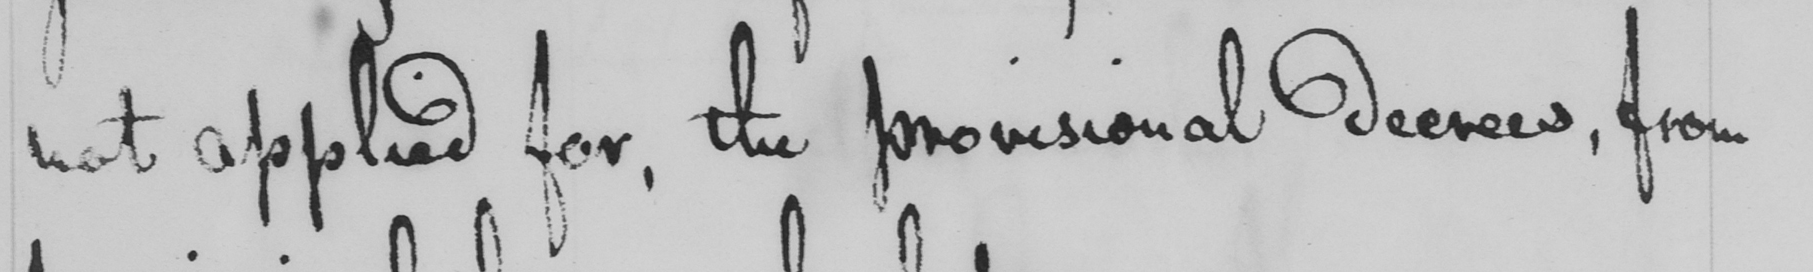Can you read and transcribe this handwriting? not applied for, the provisional decrees, from 